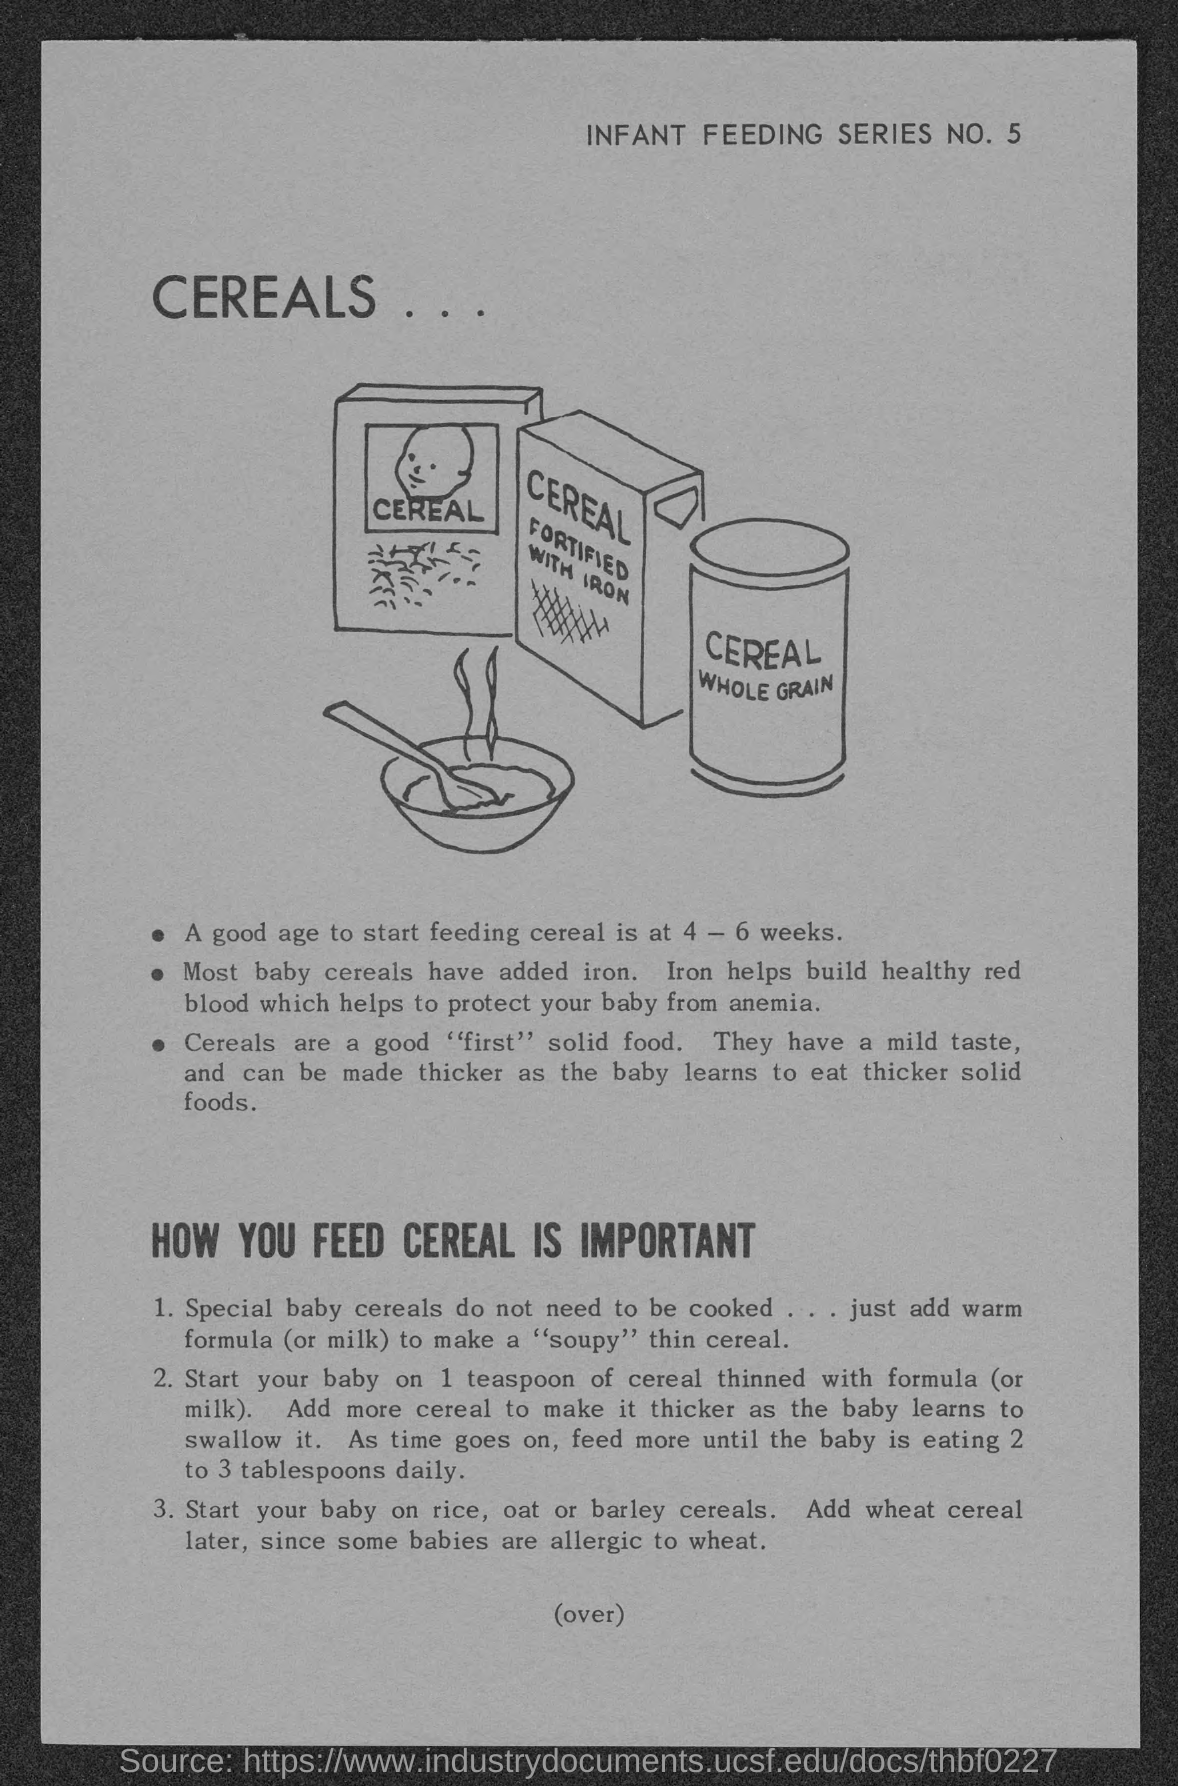What is the infant feeding series no.?
Your response must be concise. 5. What is the heading at top of the page ?
Offer a very short reply. Cereals. 